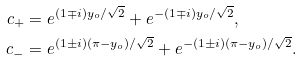Convert formula to latex. <formula><loc_0><loc_0><loc_500><loc_500>c _ { + } & = e ^ { ( 1 \mp i ) y _ { o } / \sqrt { 2 } } + e ^ { - ( 1 \mp i ) y _ { o } / \sqrt { 2 } } , \\ c _ { - } & = e ^ { ( 1 \pm i ) ( \pi - y _ { o } ) / \sqrt { 2 } } + e ^ { - ( 1 \pm i ) ( \pi - y _ { o } ) / \sqrt { 2 } } .</formula> 